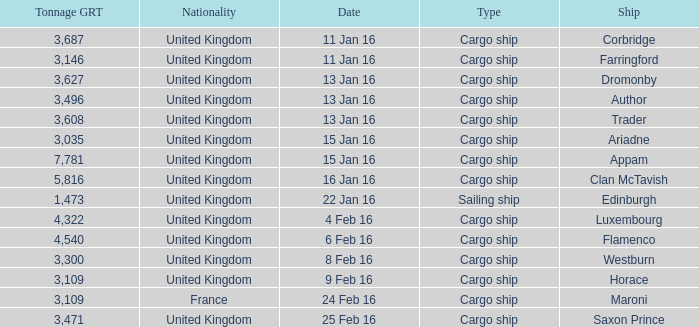What is the most tonnage grt of any ship sunk or captured on 16 jan 16? 5816.0. 